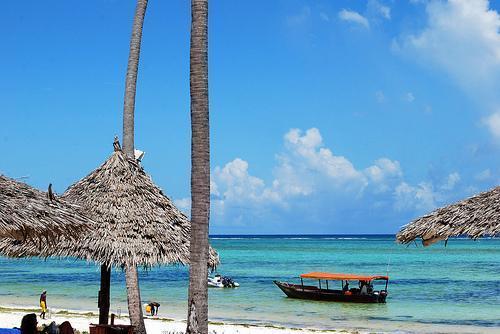How many tree trunks are visible?
Give a very brief answer. 2. How many black boats are visible?
Give a very brief answer. 1. How many tiki hut roofs are visible?
Give a very brief answer. 3. How many people are walking on the sea?
Give a very brief answer. 0. 